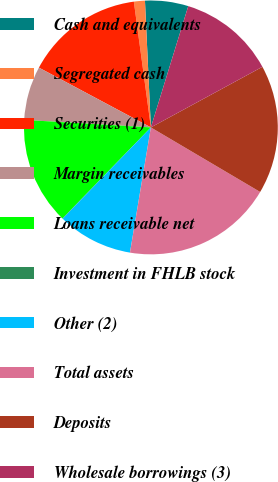Convert chart. <chart><loc_0><loc_0><loc_500><loc_500><pie_chart><fcel>Cash and equivalents<fcel>Segregated cash<fcel>Securities (1)<fcel>Margin receivables<fcel>Loans receivable net<fcel>Investment in FHLB stock<fcel>Other (2)<fcel>Total assets<fcel>Deposits<fcel>Wholesale borrowings (3)<nl><fcel>5.5%<fcel>1.4%<fcel>15.05%<fcel>6.86%<fcel>13.68%<fcel>0.04%<fcel>9.59%<fcel>19.14%<fcel>16.41%<fcel>12.32%<nl></chart> 